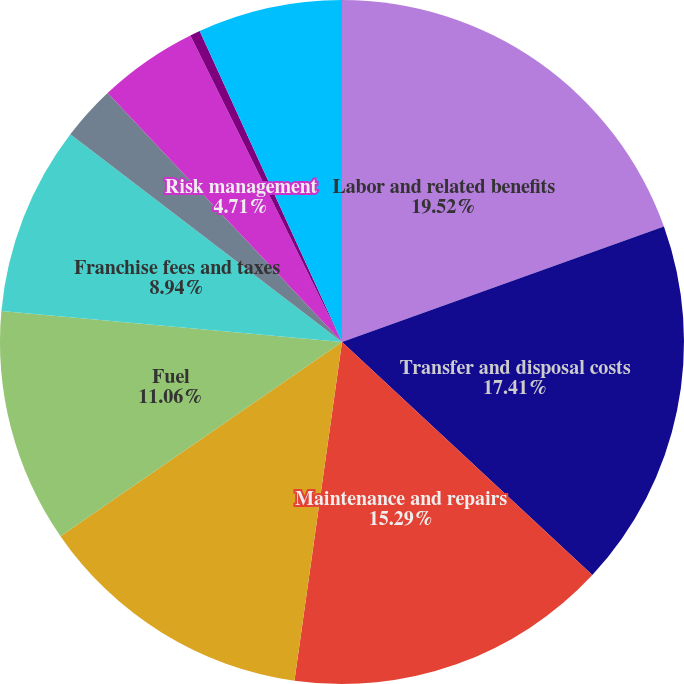<chart> <loc_0><loc_0><loc_500><loc_500><pie_chart><fcel>Labor and related benefits<fcel>Transfer and disposal costs<fcel>Maintenance and repairs<fcel>Transportation and subcontract<fcel>Fuel<fcel>Franchise fees and taxes<fcel>Landfill operating costs<fcel>Risk management<fcel>Cost of goods sold<fcel>Other<nl><fcel>19.52%<fcel>17.41%<fcel>15.29%<fcel>13.17%<fcel>11.06%<fcel>8.94%<fcel>2.59%<fcel>4.71%<fcel>0.48%<fcel>6.83%<nl></chart> 